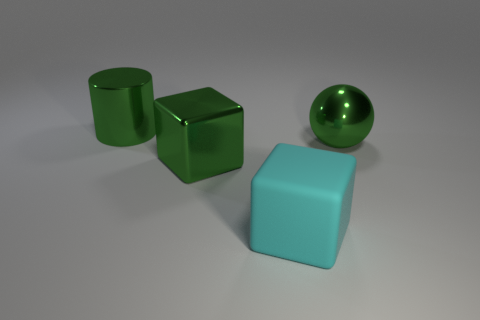Add 3 large rubber blocks. How many objects exist? 7 Add 1 big shiny spheres. How many big shiny spheres exist? 2 Subtract 0 red cubes. How many objects are left? 4 Subtract all balls. How many objects are left? 3 Subtract all brown cylinders. Subtract all purple spheres. How many cylinders are left? 1 Subtract all big brown objects. Subtract all big cylinders. How many objects are left? 3 Add 3 big blocks. How many big blocks are left? 5 